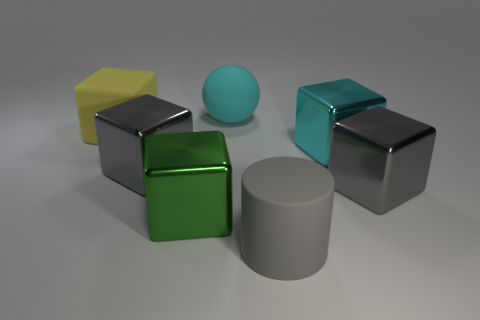Subtract all green blocks. How many blocks are left? 4 Subtract 1 blocks. How many blocks are left? 4 Subtract all blue blocks. Subtract all red spheres. How many blocks are left? 5 Add 3 tiny purple rubber cylinders. How many objects exist? 10 Subtract all blocks. How many objects are left? 2 Add 5 cyan objects. How many cyan objects are left? 7 Add 5 big cubes. How many big cubes exist? 10 Subtract 0 brown spheres. How many objects are left? 7 Subtract all small yellow things. Subtract all yellow matte things. How many objects are left? 6 